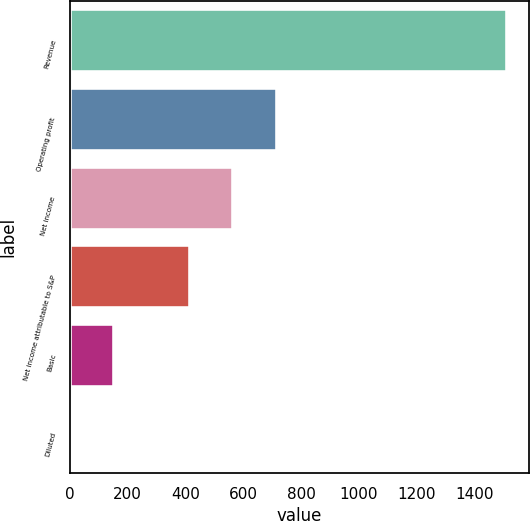<chart> <loc_0><loc_0><loc_500><loc_500><bar_chart><fcel>Revenue<fcel>Operating profit<fcel>Net income<fcel>Net income attributable to S&P<fcel>Basic<fcel>Diluted<nl><fcel>1513<fcel>716.28<fcel>565.14<fcel>414<fcel>152.75<fcel>1.61<nl></chart> 